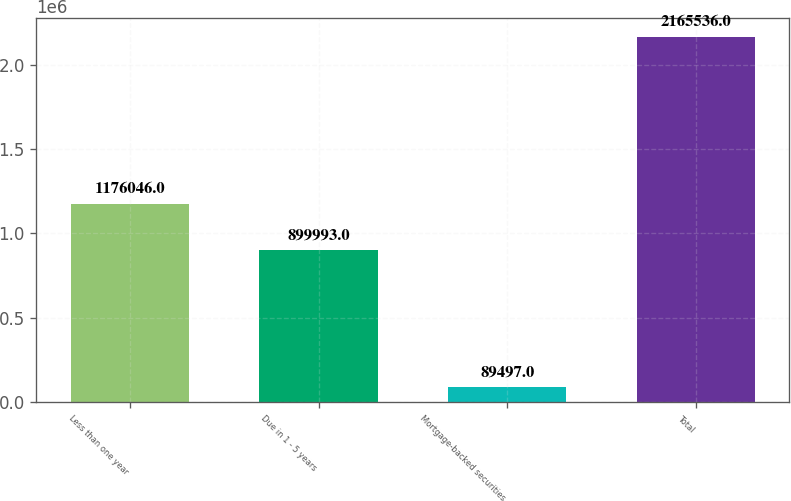Convert chart to OTSL. <chart><loc_0><loc_0><loc_500><loc_500><bar_chart><fcel>Less than one year<fcel>Due in 1 - 5 years<fcel>Mortgage-backed securities<fcel>Total<nl><fcel>1.17605e+06<fcel>899993<fcel>89497<fcel>2.16554e+06<nl></chart> 